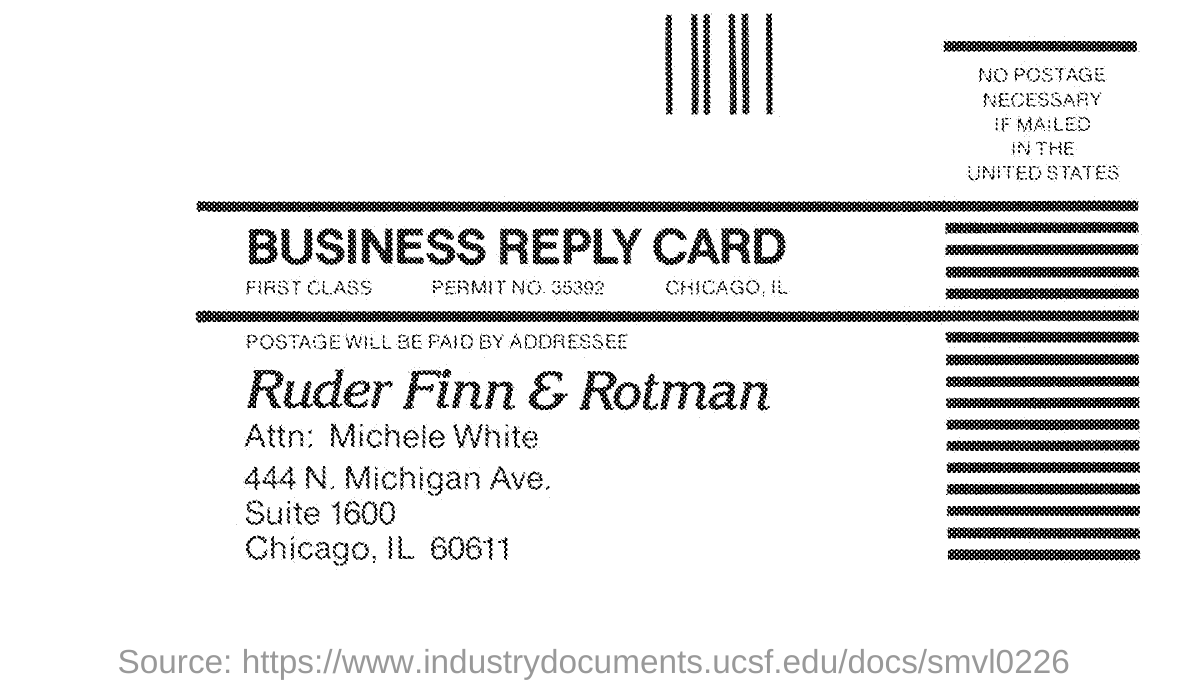Give some essential details in this illustration. The permit number mentioned in the business reply card is 35392. 